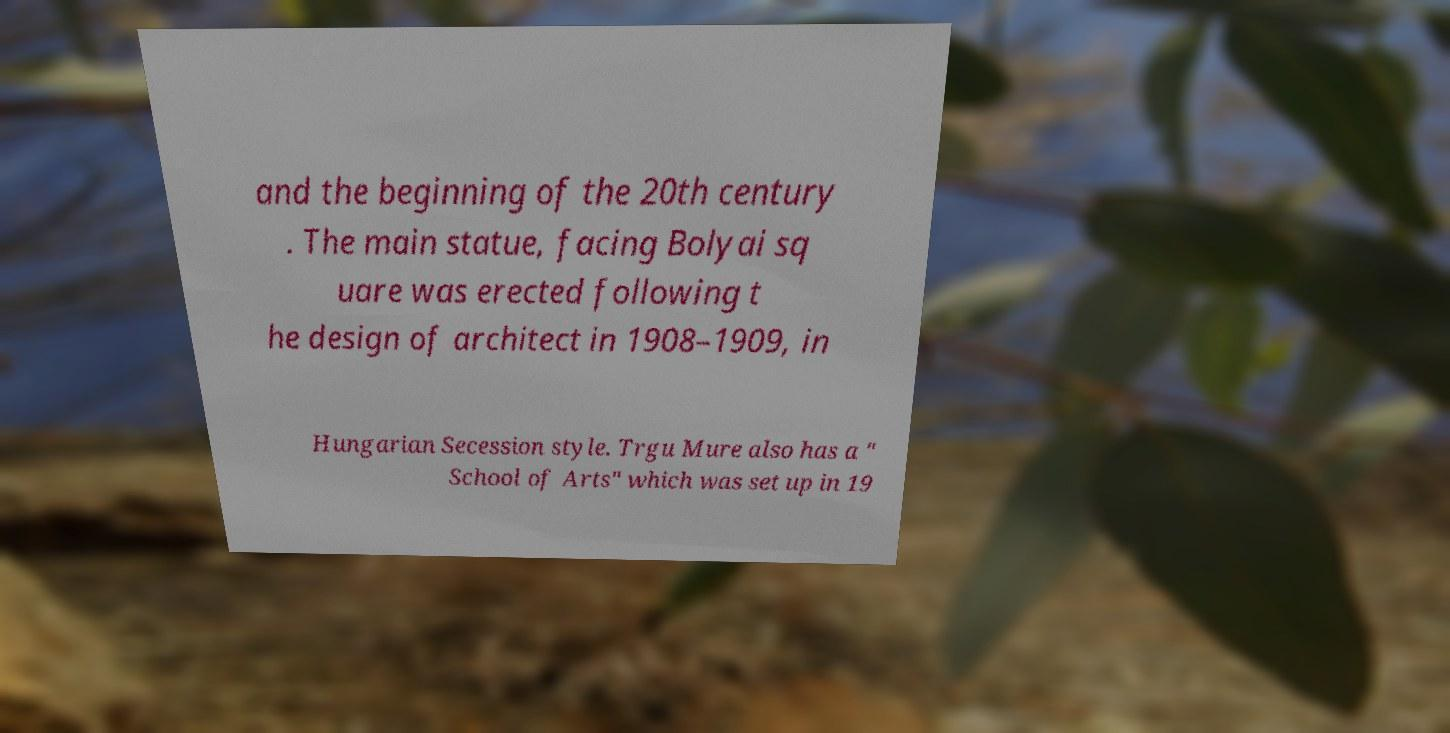Please read and relay the text visible in this image. What does it say? and the beginning of the 20th century . The main statue, facing Bolyai sq uare was erected following t he design of architect in 1908–1909, in Hungarian Secession style. Trgu Mure also has a " School of Arts" which was set up in 19 